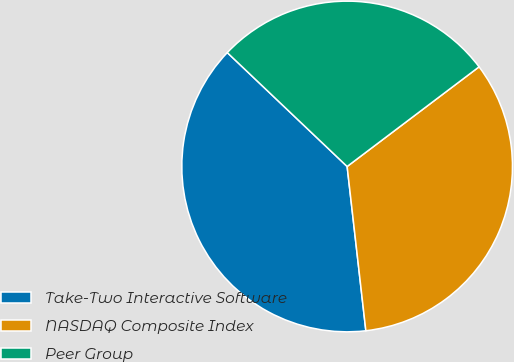Convert chart. <chart><loc_0><loc_0><loc_500><loc_500><pie_chart><fcel>Take-Two Interactive Software<fcel>NASDAQ Composite Index<fcel>Peer Group<nl><fcel>38.9%<fcel>33.49%<fcel>27.61%<nl></chart> 